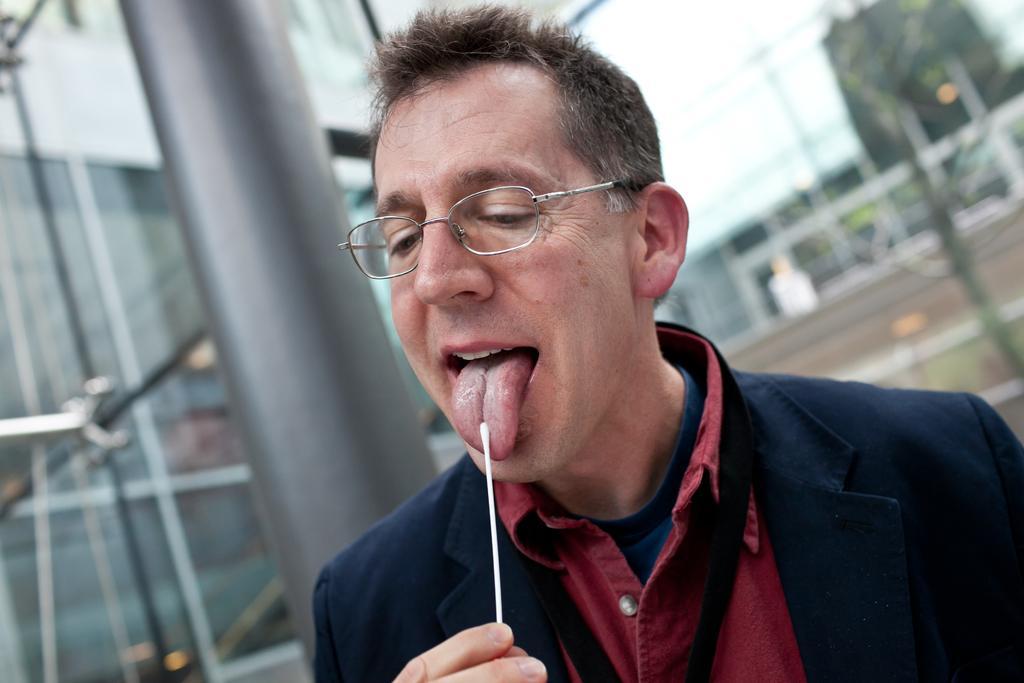Please provide a concise description of this image. In the image we can see a man wearing clothes, spectacles and the man is holding a stick in his hand. Behind him we can see glass construction and the background is blurred. 